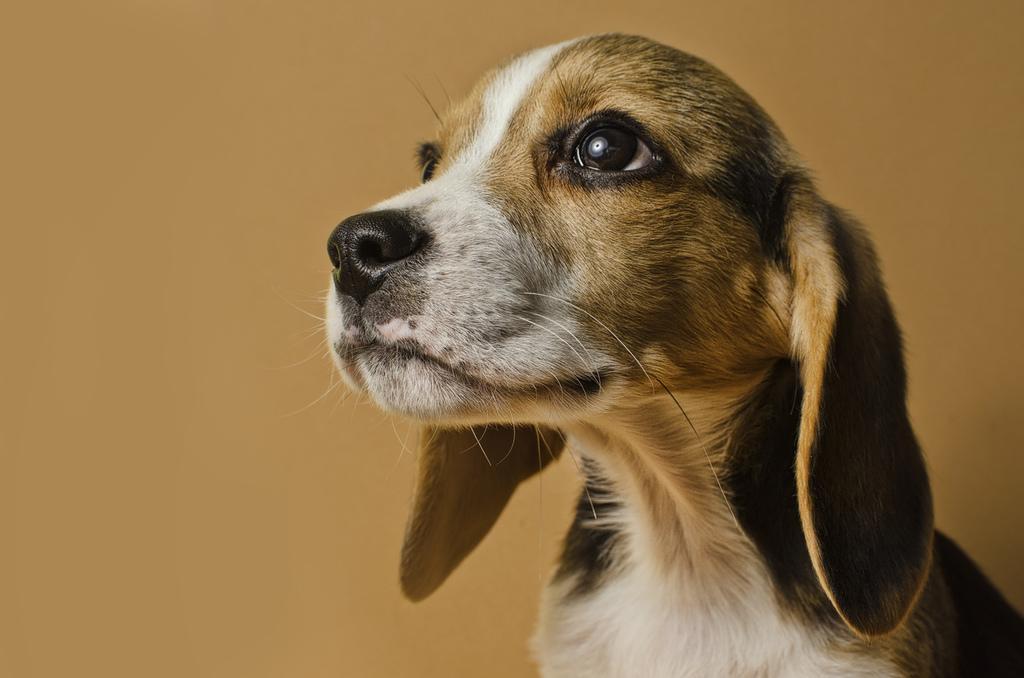Could you give a brief overview of what you see in this image? In this image there is a dog. In the background we can see a wall. 